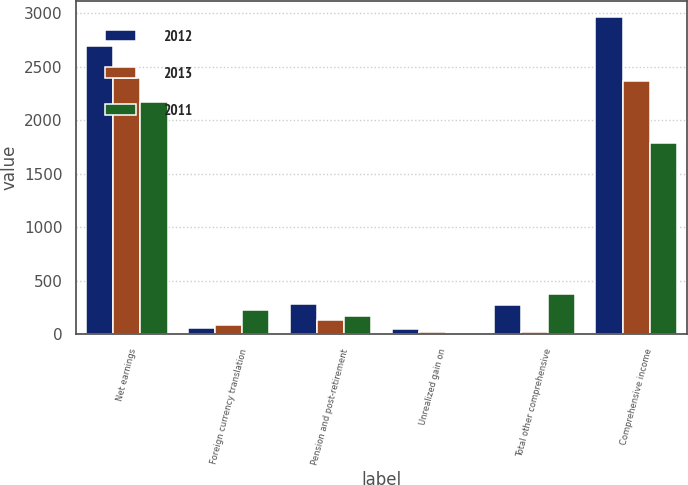Convert chart. <chart><loc_0><loc_0><loc_500><loc_500><stacked_bar_chart><ecel><fcel>Net earnings<fcel>Foreign currency translation<fcel>Pension and post-retirement<fcel>Unrealized gain on<fcel>Total other comprehensive<fcel>Comprehensive income<nl><fcel>2012<fcel>2695<fcel>62.1<fcel>289<fcel>46.8<fcel>273.7<fcel>2968.7<nl><fcel>2013<fcel>2392.2<fcel>90.8<fcel>139.7<fcel>26.6<fcel>22.3<fcel>2369.9<nl><fcel>2011<fcel>2172.3<fcel>226.8<fcel>171.2<fcel>15.7<fcel>382.3<fcel>1790<nl></chart> 